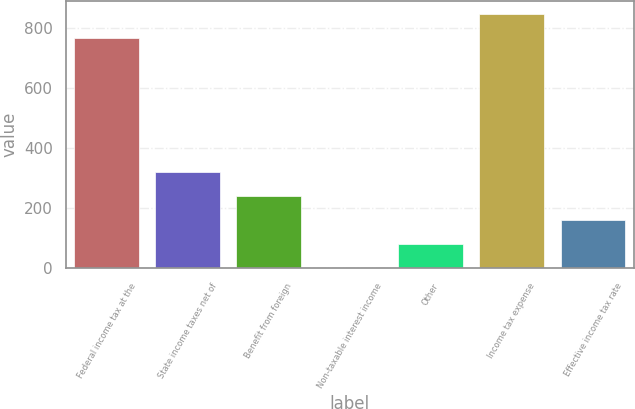<chart> <loc_0><loc_0><loc_500><loc_500><bar_chart><fcel>Federal income tax at the<fcel>State income taxes net of<fcel>Benefit from foreign<fcel>Non-taxable interest income<fcel>Other<fcel>Income tax expense<fcel>Effective income tax rate<nl><fcel>768<fcel>321.4<fcel>241.3<fcel>1<fcel>81.1<fcel>848.1<fcel>161.2<nl></chart> 